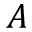Convert formula to latex. <formula><loc_0><loc_0><loc_500><loc_500>A</formula> 